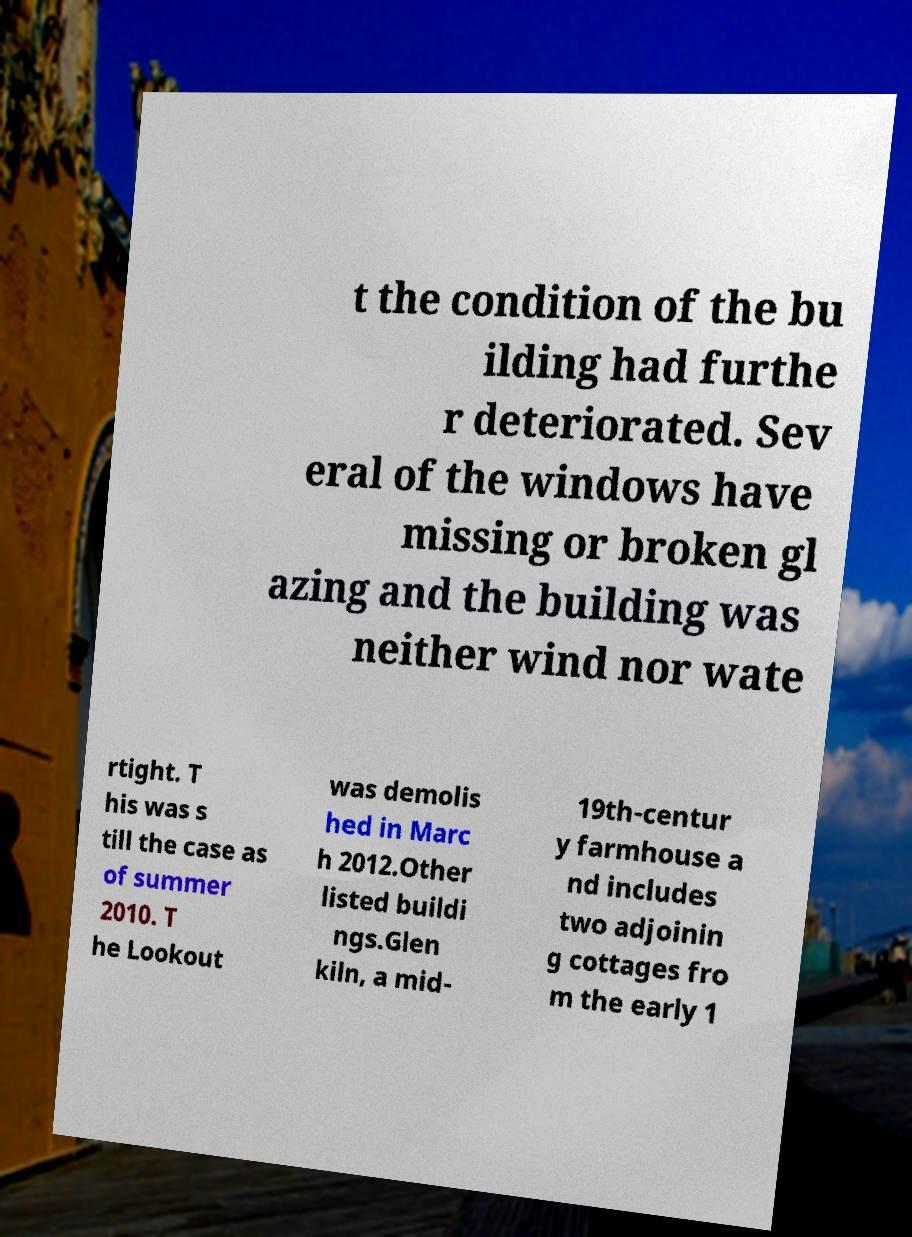Can you read and provide the text displayed in the image?This photo seems to have some interesting text. Can you extract and type it out for me? t the condition of the bu ilding had furthe r deteriorated. Sev eral of the windows have missing or broken gl azing and the building was neither wind nor wate rtight. T his was s till the case as of summer 2010. T he Lookout was demolis hed in Marc h 2012.Other listed buildi ngs.Glen kiln, a mid- 19th-centur y farmhouse a nd includes two adjoinin g cottages fro m the early 1 